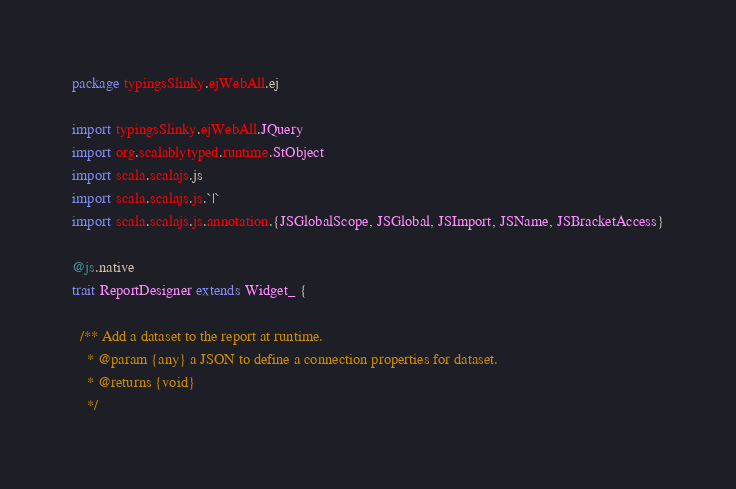Convert code to text. <code><loc_0><loc_0><loc_500><loc_500><_Scala_>package typingsSlinky.ejWebAll.ej

import typingsSlinky.ejWebAll.JQuery
import org.scalablytyped.runtime.StObject
import scala.scalajs.js
import scala.scalajs.js.`|`
import scala.scalajs.js.annotation.{JSGlobalScope, JSGlobal, JSImport, JSName, JSBracketAccess}

@js.native
trait ReportDesigner extends Widget_ {
  
  /** Add a dataset to the report at runtime.
    * @param {any} a JSON to define a connection properties for dataset.
    * @returns {void}
    */</code> 